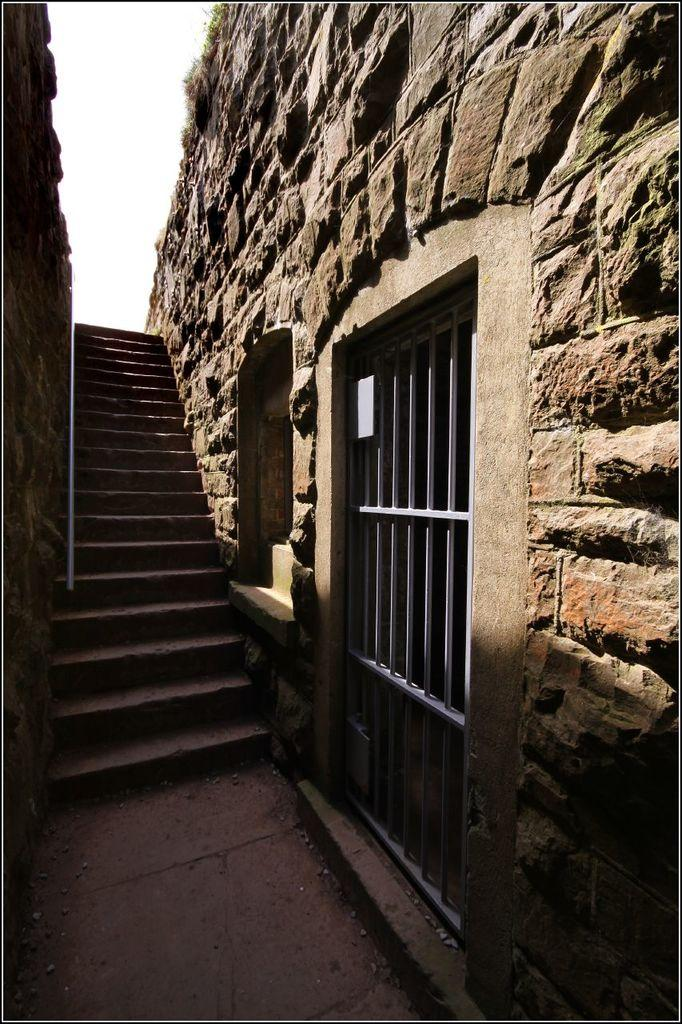What type of structure is present in the image? There is a staircase in the image. What surrounds the staircase? There are walls on both sides of the staircase. What can be seen on the right side of the image? There is a metal gate and a window in the wall on the right side of the image. What is visible at the top of the image? The sky is visible at the top of the image. What type of pencil can be seen being used to draw on the walls in the image? There is no pencil or drawing activity present in the image. 